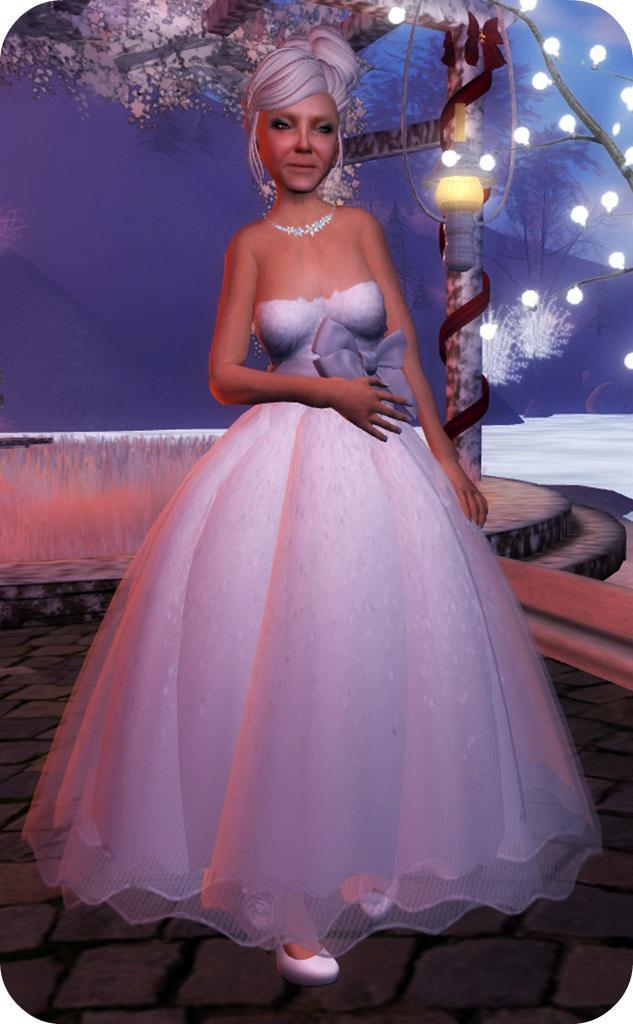What is the main subject of the image? There is a depiction of a woman in the image. What is the woman wearing in the image? The woman is wearing a white dress and a necklace. What else can be seen in the image besides the woman? There are lights visible in the image. What decision does the woman's son make in the image? There is no son present in the image, so no decision can be attributed to him. 